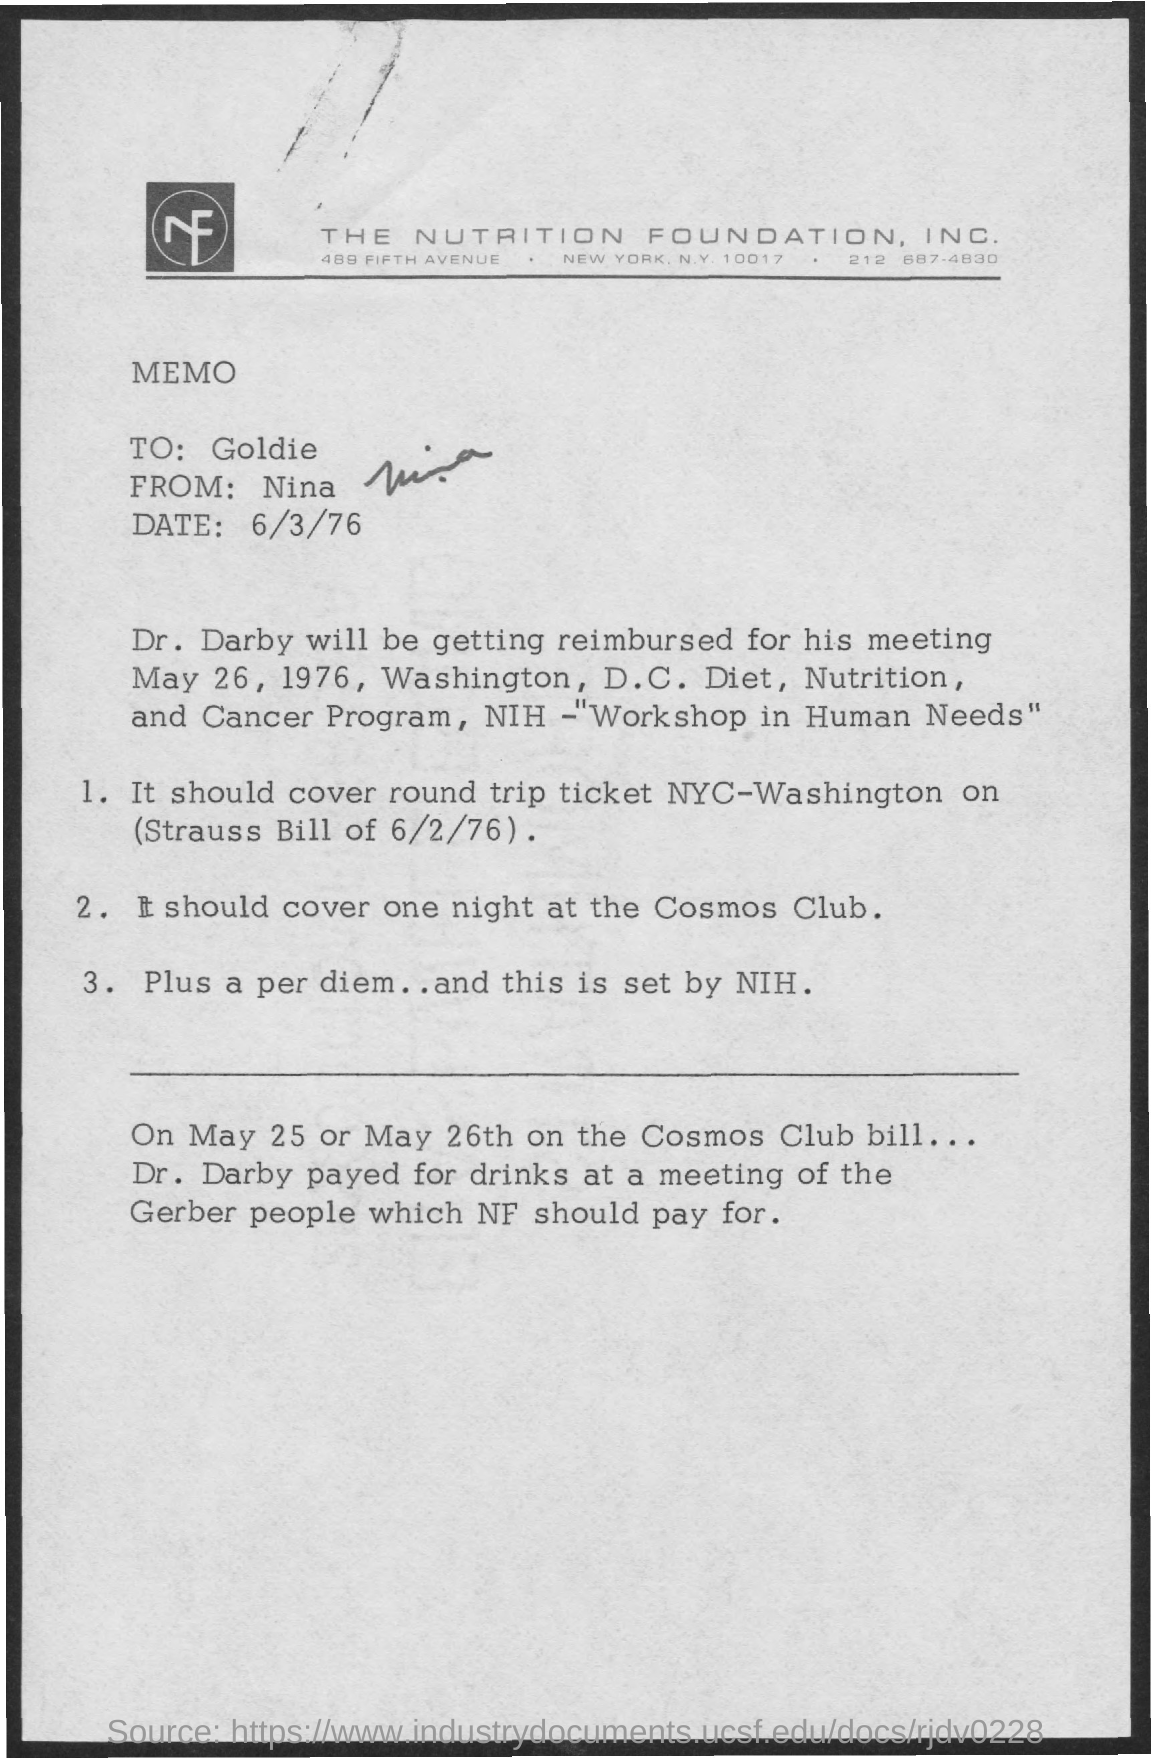Who is the Memorandum Addressed to ?
Ensure brevity in your answer.  Goldie. Who is the memorandum from ?
Your response must be concise. Nina. What is the date mentioned in the top of the document ?
Your answer should be very brief. 6/3/76. 